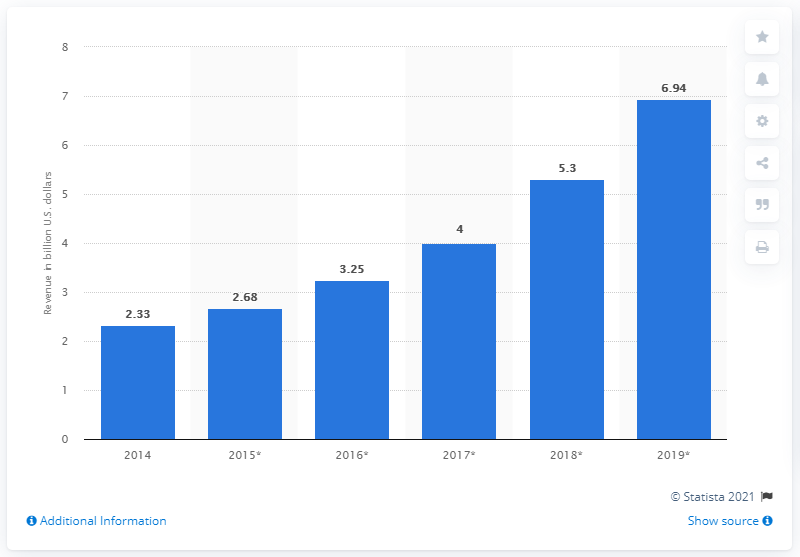Draw attention to some important aspects in this diagram. In the year 2014, the smart home market generated revenue in the UK. The expected smart home market revenues in the United States by 2019 were approximately $6.94 billion. 